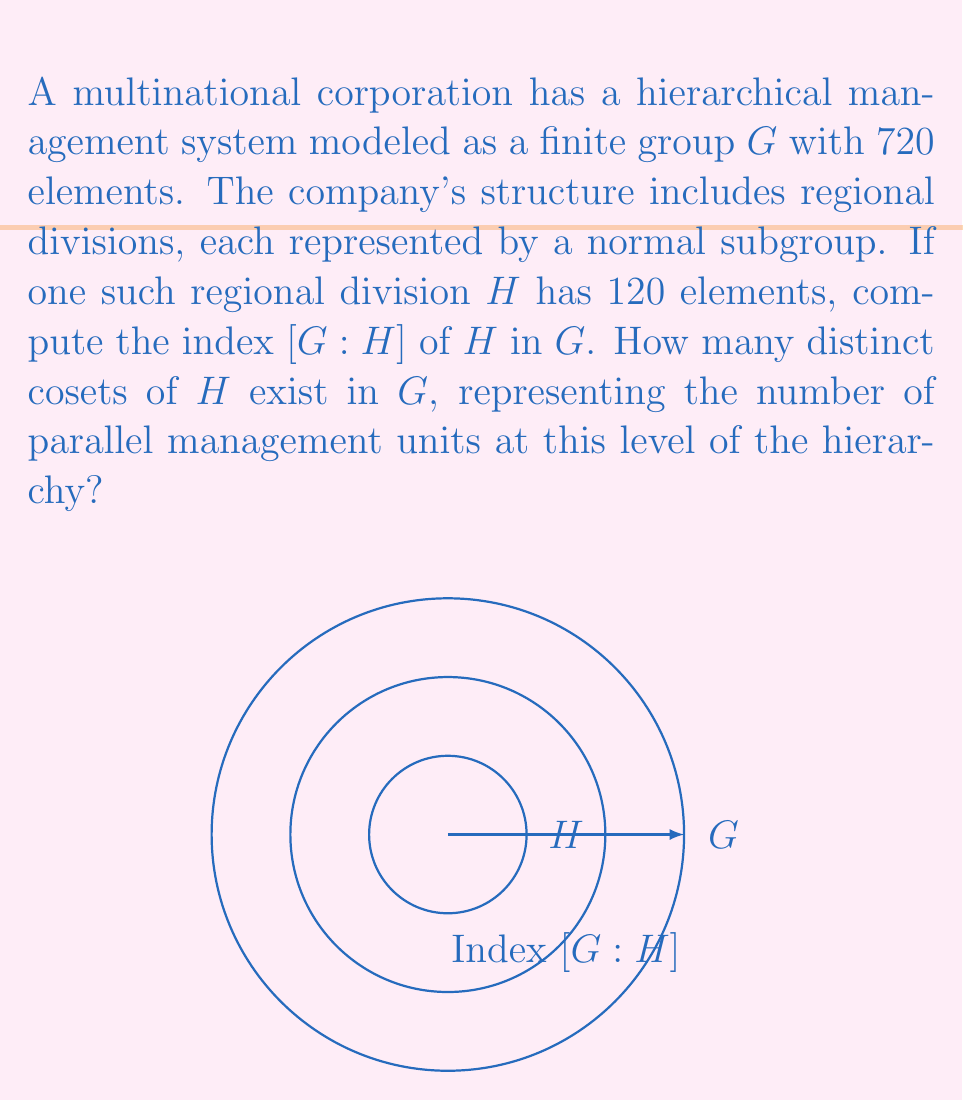Can you answer this question? To solve this problem, we'll follow these steps:

1) Recall the definition of the index of a subgroup:
   For a group $G$ and its subgroup $H$, the index $[G:H]$ is defined as the number of distinct left (or right) cosets of $H$ in $G$.

2) The index $[G:H]$ is also equal to the quotient of the orders of $G$ and $H$:

   $$[G:H] = \frac{|G|}{|H|}$$

   Where $|G|$ denotes the order (number of elements) of $G$, and $|H|$ the order of $H$.

3) We are given:
   $|G| = 720$ (the total number of elements in the corporation's management structure)
   $|H| = 120$ (the number of elements in the regional division)

4) Substituting these values into the formula:

   $$[G:H] = \frac{|G|}{|H|} = \frac{720}{120}$$

5) Simplify the fraction:

   $$[G:H] = \frac{720}{120} = 6$$

6) Therefore, the index $[G:H]$ is 6, which means there are 6 distinct cosets of $H$ in $G$.

This result indicates that there are 6 parallel management units at this level of the hierarchy, each represented by a coset of the regional division $H$ in the overall corporate structure $G$.
Answer: $[G:H] = 6$ 